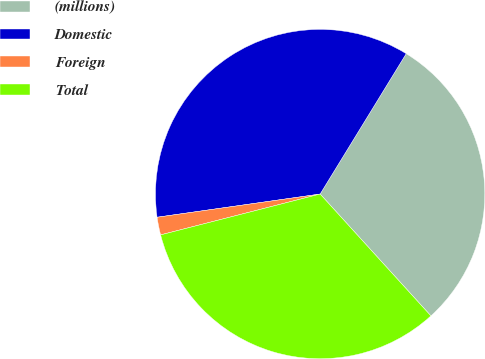Convert chart to OTSL. <chart><loc_0><loc_0><loc_500><loc_500><pie_chart><fcel>(millions)<fcel>Domestic<fcel>Foreign<fcel>Total<nl><fcel>29.5%<fcel>36.0%<fcel>1.74%<fcel>32.75%<nl></chart> 